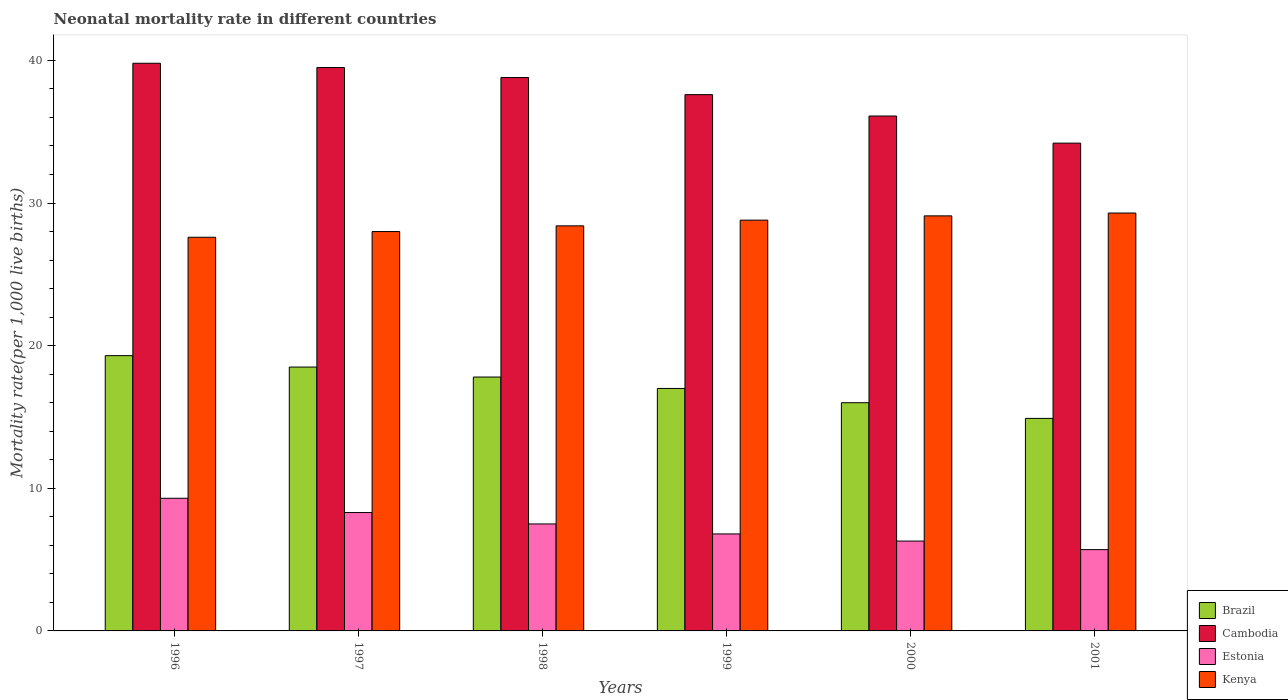How many groups of bars are there?
Provide a short and direct response. 6. How many bars are there on the 1st tick from the left?
Your answer should be compact. 4. What is the neonatal mortality rate in Cambodia in 1997?
Keep it short and to the point. 39.5. Across all years, what is the maximum neonatal mortality rate in Brazil?
Your answer should be compact. 19.3. Across all years, what is the minimum neonatal mortality rate in Cambodia?
Make the answer very short. 34.2. What is the total neonatal mortality rate in Kenya in the graph?
Provide a short and direct response. 171.2. What is the difference between the neonatal mortality rate in Estonia in 1997 and that in 2001?
Your response must be concise. 2.6. What is the difference between the neonatal mortality rate in Cambodia in 2001 and the neonatal mortality rate in Estonia in 1999?
Your response must be concise. 27.4. What is the average neonatal mortality rate in Cambodia per year?
Your response must be concise. 37.67. In the year 1999, what is the difference between the neonatal mortality rate in Kenya and neonatal mortality rate in Brazil?
Ensure brevity in your answer.  11.8. What is the ratio of the neonatal mortality rate in Estonia in 1997 to that in 2000?
Give a very brief answer. 1.32. What is the difference between the highest and the second highest neonatal mortality rate in Estonia?
Your response must be concise. 1. What is the difference between the highest and the lowest neonatal mortality rate in Estonia?
Give a very brief answer. 3.6. Is the sum of the neonatal mortality rate in Brazil in 2000 and 2001 greater than the maximum neonatal mortality rate in Cambodia across all years?
Give a very brief answer. No. What does the 2nd bar from the left in 1996 represents?
Provide a short and direct response. Cambodia. Is it the case that in every year, the sum of the neonatal mortality rate in Cambodia and neonatal mortality rate in Estonia is greater than the neonatal mortality rate in Brazil?
Provide a succinct answer. Yes. How many bars are there?
Ensure brevity in your answer.  24. How many years are there in the graph?
Offer a very short reply. 6. What is the difference between two consecutive major ticks on the Y-axis?
Provide a short and direct response. 10. Are the values on the major ticks of Y-axis written in scientific E-notation?
Offer a terse response. No. Does the graph contain any zero values?
Make the answer very short. No. How many legend labels are there?
Keep it short and to the point. 4. What is the title of the graph?
Your response must be concise. Neonatal mortality rate in different countries. What is the label or title of the X-axis?
Offer a terse response. Years. What is the label or title of the Y-axis?
Offer a very short reply. Mortality rate(per 1,0 live births). What is the Mortality rate(per 1,000 live births) in Brazil in 1996?
Your response must be concise. 19.3. What is the Mortality rate(per 1,000 live births) in Cambodia in 1996?
Give a very brief answer. 39.8. What is the Mortality rate(per 1,000 live births) of Estonia in 1996?
Provide a short and direct response. 9.3. What is the Mortality rate(per 1,000 live births) of Kenya in 1996?
Offer a terse response. 27.6. What is the Mortality rate(per 1,000 live births) of Brazil in 1997?
Offer a very short reply. 18.5. What is the Mortality rate(per 1,000 live births) in Cambodia in 1997?
Offer a very short reply. 39.5. What is the Mortality rate(per 1,000 live births) in Estonia in 1997?
Keep it short and to the point. 8.3. What is the Mortality rate(per 1,000 live births) in Brazil in 1998?
Offer a very short reply. 17.8. What is the Mortality rate(per 1,000 live births) in Cambodia in 1998?
Your response must be concise. 38.8. What is the Mortality rate(per 1,000 live births) in Kenya in 1998?
Provide a succinct answer. 28.4. What is the Mortality rate(per 1,000 live births) in Brazil in 1999?
Your response must be concise. 17. What is the Mortality rate(per 1,000 live births) in Cambodia in 1999?
Offer a terse response. 37.6. What is the Mortality rate(per 1,000 live births) in Kenya in 1999?
Keep it short and to the point. 28.8. What is the Mortality rate(per 1,000 live births) of Brazil in 2000?
Provide a short and direct response. 16. What is the Mortality rate(per 1,000 live births) of Cambodia in 2000?
Provide a succinct answer. 36.1. What is the Mortality rate(per 1,000 live births) of Kenya in 2000?
Your response must be concise. 29.1. What is the Mortality rate(per 1,000 live births) of Brazil in 2001?
Your answer should be very brief. 14.9. What is the Mortality rate(per 1,000 live births) of Cambodia in 2001?
Ensure brevity in your answer.  34.2. What is the Mortality rate(per 1,000 live births) of Kenya in 2001?
Keep it short and to the point. 29.3. Across all years, what is the maximum Mortality rate(per 1,000 live births) in Brazil?
Give a very brief answer. 19.3. Across all years, what is the maximum Mortality rate(per 1,000 live births) of Cambodia?
Provide a succinct answer. 39.8. Across all years, what is the maximum Mortality rate(per 1,000 live births) of Estonia?
Make the answer very short. 9.3. Across all years, what is the maximum Mortality rate(per 1,000 live births) in Kenya?
Ensure brevity in your answer.  29.3. Across all years, what is the minimum Mortality rate(per 1,000 live births) of Cambodia?
Your answer should be very brief. 34.2. Across all years, what is the minimum Mortality rate(per 1,000 live births) of Kenya?
Keep it short and to the point. 27.6. What is the total Mortality rate(per 1,000 live births) in Brazil in the graph?
Your answer should be compact. 103.5. What is the total Mortality rate(per 1,000 live births) in Cambodia in the graph?
Keep it short and to the point. 226. What is the total Mortality rate(per 1,000 live births) of Estonia in the graph?
Keep it short and to the point. 43.9. What is the total Mortality rate(per 1,000 live births) in Kenya in the graph?
Your answer should be very brief. 171.2. What is the difference between the Mortality rate(per 1,000 live births) of Brazil in 1996 and that in 1997?
Give a very brief answer. 0.8. What is the difference between the Mortality rate(per 1,000 live births) of Cambodia in 1996 and that in 1998?
Offer a very short reply. 1. What is the difference between the Mortality rate(per 1,000 live births) in Estonia in 1996 and that in 1998?
Your answer should be compact. 1.8. What is the difference between the Mortality rate(per 1,000 live births) of Kenya in 1996 and that in 1998?
Make the answer very short. -0.8. What is the difference between the Mortality rate(per 1,000 live births) in Brazil in 1996 and that in 1999?
Give a very brief answer. 2.3. What is the difference between the Mortality rate(per 1,000 live births) of Estonia in 1996 and that in 1999?
Provide a succinct answer. 2.5. What is the difference between the Mortality rate(per 1,000 live births) of Kenya in 1996 and that in 1999?
Give a very brief answer. -1.2. What is the difference between the Mortality rate(per 1,000 live births) in Cambodia in 1996 and that in 2000?
Keep it short and to the point. 3.7. What is the difference between the Mortality rate(per 1,000 live births) in Kenya in 1996 and that in 2000?
Offer a very short reply. -1.5. What is the difference between the Mortality rate(per 1,000 live births) of Estonia in 1996 and that in 2001?
Offer a very short reply. 3.6. What is the difference between the Mortality rate(per 1,000 live births) of Brazil in 1997 and that in 1998?
Offer a very short reply. 0.7. What is the difference between the Mortality rate(per 1,000 live births) in Estonia in 1997 and that in 1998?
Provide a succinct answer. 0.8. What is the difference between the Mortality rate(per 1,000 live births) of Kenya in 1997 and that in 1998?
Ensure brevity in your answer.  -0.4. What is the difference between the Mortality rate(per 1,000 live births) in Cambodia in 1997 and that in 1999?
Give a very brief answer. 1.9. What is the difference between the Mortality rate(per 1,000 live births) in Estonia in 1997 and that in 1999?
Keep it short and to the point. 1.5. What is the difference between the Mortality rate(per 1,000 live births) of Brazil in 1997 and that in 2000?
Provide a short and direct response. 2.5. What is the difference between the Mortality rate(per 1,000 live births) in Cambodia in 1997 and that in 2000?
Offer a very short reply. 3.4. What is the difference between the Mortality rate(per 1,000 live births) in Estonia in 1997 and that in 2000?
Keep it short and to the point. 2. What is the difference between the Mortality rate(per 1,000 live births) in Brazil in 1997 and that in 2001?
Your answer should be compact. 3.6. What is the difference between the Mortality rate(per 1,000 live births) in Kenya in 1997 and that in 2001?
Your answer should be very brief. -1.3. What is the difference between the Mortality rate(per 1,000 live births) of Cambodia in 1998 and that in 1999?
Your answer should be very brief. 1.2. What is the difference between the Mortality rate(per 1,000 live births) in Brazil in 1998 and that in 2000?
Keep it short and to the point. 1.8. What is the difference between the Mortality rate(per 1,000 live births) in Kenya in 1998 and that in 2000?
Offer a terse response. -0.7. What is the difference between the Mortality rate(per 1,000 live births) in Brazil in 1998 and that in 2001?
Provide a succinct answer. 2.9. What is the difference between the Mortality rate(per 1,000 live births) of Estonia in 1998 and that in 2001?
Your answer should be very brief. 1.8. What is the difference between the Mortality rate(per 1,000 live births) in Cambodia in 1999 and that in 2000?
Offer a very short reply. 1.5. What is the difference between the Mortality rate(per 1,000 live births) in Estonia in 1999 and that in 2000?
Provide a short and direct response. 0.5. What is the difference between the Mortality rate(per 1,000 live births) in Kenya in 1999 and that in 2000?
Your response must be concise. -0.3. What is the difference between the Mortality rate(per 1,000 live births) in Kenya in 1999 and that in 2001?
Give a very brief answer. -0.5. What is the difference between the Mortality rate(per 1,000 live births) in Brazil in 1996 and the Mortality rate(per 1,000 live births) in Cambodia in 1997?
Give a very brief answer. -20.2. What is the difference between the Mortality rate(per 1,000 live births) in Cambodia in 1996 and the Mortality rate(per 1,000 live births) in Estonia in 1997?
Offer a terse response. 31.5. What is the difference between the Mortality rate(per 1,000 live births) of Estonia in 1996 and the Mortality rate(per 1,000 live births) of Kenya in 1997?
Give a very brief answer. -18.7. What is the difference between the Mortality rate(per 1,000 live births) of Brazil in 1996 and the Mortality rate(per 1,000 live births) of Cambodia in 1998?
Give a very brief answer. -19.5. What is the difference between the Mortality rate(per 1,000 live births) in Brazil in 1996 and the Mortality rate(per 1,000 live births) in Estonia in 1998?
Ensure brevity in your answer.  11.8. What is the difference between the Mortality rate(per 1,000 live births) in Brazil in 1996 and the Mortality rate(per 1,000 live births) in Kenya in 1998?
Give a very brief answer. -9.1. What is the difference between the Mortality rate(per 1,000 live births) in Cambodia in 1996 and the Mortality rate(per 1,000 live births) in Estonia in 1998?
Provide a succinct answer. 32.3. What is the difference between the Mortality rate(per 1,000 live births) in Cambodia in 1996 and the Mortality rate(per 1,000 live births) in Kenya in 1998?
Provide a succinct answer. 11.4. What is the difference between the Mortality rate(per 1,000 live births) of Estonia in 1996 and the Mortality rate(per 1,000 live births) of Kenya in 1998?
Provide a short and direct response. -19.1. What is the difference between the Mortality rate(per 1,000 live births) in Brazil in 1996 and the Mortality rate(per 1,000 live births) in Cambodia in 1999?
Your answer should be compact. -18.3. What is the difference between the Mortality rate(per 1,000 live births) of Cambodia in 1996 and the Mortality rate(per 1,000 live births) of Estonia in 1999?
Give a very brief answer. 33. What is the difference between the Mortality rate(per 1,000 live births) of Cambodia in 1996 and the Mortality rate(per 1,000 live births) of Kenya in 1999?
Provide a succinct answer. 11. What is the difference between the Mortality rate(per 1,000 live births) in Estonia in 1996 and the Mortality rate(per 1,000 live births) in Kenya in 1999?
Ensure brevity in your answer.  -19.5. What is the difference between the Mortality rate(per 1,000 live births) in Brazil in 1996 and the Mortality rate(per 1,000 live births) in Cambodia in 2000?
Your response must be concise. -16.8. What is the difference between the Mortality rate(per 1,000 live births) in Brazil in 1996 and the Mortality rate(per 1,000 live births) in Kenya in 2000?
Offer a terse response. -9.8. What is the difference between the Mortality rate(per 1,000 live births) of Cambodia in 1996 and the Mortality rate(per 1,000 live births) of Estonia in 2000?
Your answer should be compact. 33.5. What is the difference between the Mortality rate(per 1,000 live births) of Estonia in 1996 and the Mortality rate(per 1,000 live births) of Kenya in 2000?
Offer a very short reply. -19.8. What is the difference between the Mortality rate(per 1,000 live births) of Brazil in 1996 and the Mortality rate(per 1,000 live births) of Cambodia in 2001?
Give a very brief answer. -14.9. What is the difference between the Mortality rate(per 1,000 live births) in Brazil in 1996 and the Mortality rate(per 1,000 live births) in Estonia in 2001?
Your answer should be very brief. 13.6. What is the difference between the Mortality rate(per 1,000 live births) of Cambodia in 1996 and the Mortality rate(per 1,000 live births) of Estonia in 2001?
Your answer should be compact. 34.1. What is the difference between the Mortality rate(per 1,000 live births) of Cambodia in 1996 and the Mortality rate(per 1,000 live births) of Kenya in 2001?
Ensure brevity in your answer.  10.5. What is the difference between the Mortality rate(per 1,000 live births) of Estonia in 1996 and the Mortality rate(per 1,000 live births) of Kenya in 2001?
Provide a succinct answer. -20. What is the difference between the Mortality rate(per 1,000 live births) in Brazil in 1997 and the Mortality rate(per 1,000 live births) in Cambodia in 1998?
Your answer should be very brief. -20.3. What is the difference between the Mortality rate(per 1,000 live births) in Brazil in 1997 and the Mortality rate(per 1,000 live births) in Estonia in 1998?
Ensure brevity in your answer.  11. What is the difference between the Mortality rate(per 1,000 live births) of Cambodia in 1997 and the Mortality rate(per 1,000 live births) of Estonia in 1998?
Give a very brief answer. 32. What is the difference between the Mortality rate(per 1,000 live births) of Estonia in 1997 and the Mortality rate(per 1,000 live births) of Kenya in 1998?
Provide a short and direct response. -20.1. What is the difference between the Mortality rate(per 1,000 live births) of Brazil in 1997 and the Mortality rate(per 1,000 live births) of Cambodia in 1999?
Offer a terse response. -19.1. What is the difference between the Mortality rate(per 1,000 live births) of Brazil in 1997 and the Mortality rate(per 1,000 live births) of Estonia in 1999?
Provide a succinct answer. 11.7. What is the difference between the Mortality rate(per 1,000 live births) of Brazil in 1997 and the Mortality rate(per 1,000 live births) of Kenya in 1999?
Offer a terse response. -10.3. What is the difference between the Mortality rate(per 1,000 live births) in Cambodia in 1997 and the Mortality rate(per 1,000 live births) in Estonia in 1999?
Offer a very short reply. 32.7. What is the difference between the Mortality rate(per 1,000 live births) in Cambodia in 1997 and the Mortality rate(per 1,000 live births) in Kenya in 1999?
Keep it short and to the point. 10.7. What is the difference between the Mortality rate(per 1,000 live births) in Estonia in 1997 and the Mortality rate(per 1,000 live births) in Kenya in 1999?
Offer a very short reply. -20.5. What is the difference between the Mortality rate(per 1,000 live births) of Brazil in 1997 and the Mortality rate(per 1,000 live births) of Cambodia in 2000?
Ensure brevity in your answer.  -17.6. What is the difference between the Mortality rate(per 1,000 live births) of Brazil in 1997 and the Mortality rate(per 1,000 live births) of Estonia in 2000?
Your answer should be very brief. 12.2. What is the difference between the Mortality rate(per 1,000 live births) of Brazil in 1997 and the Mortality rate(per 1,000 live births) of Kenya in 2000?
Your answer should be very brief. -10.6. What is the difference between the Mortality rate(per 1,000 live births) of Cambodia in 1997 and the Mortality rate(per 1,000 live births) of Estonia in 2000?
Provide a short and direct response. 33.2. What is the difference between the Mortality rate(per 1,000 live births) in Cambodia in 1997 and the Mortality rate(per 1,000 live births) in Kenya in 2000?
Ensure brevity in your answer.  10.4. What is the difference between the Mortality rate(per 1,000 live births) of Estonia in 1997 and the Mortality rate(per 1,000 live births) of Kenya in 2000?
Your answer should be very brief. -20.8. What is the difference between the Mortality rate(per 1,000 live births) in Brazil in 1997 and the Mortality rate(per 1,000 live births) in Cambodia in 2001?
Offer a very short reply. -15.7. What is the difference between the Mortality rate(per 1,000 live births) in Brazil in 1997 and the Mortality rate(per 1,000 live births) in Kenya in 2001?
Make the answer very short. -10.8. What is the difference between the Mortality rate(per 1,000 live births) in Cambodia in 1997 and the Mortality rate(per 1,000 live births) in Estonia in 2001?
Keep it short and to the point. 33.8. What is the difference between the Mortality rate(per 1,000 live births) in Estonia in 1997 and the Mortality rate(per 1,000 live births) in Kenya in 2001?
Offer a very short reply. -21. What is the difference between the Mortality rate(per 1,000 live births) in Brazil in 1998 and the Mortality rate(per 1,000 live births) in Cambodia in 1999?
Your answer should be compact. -19.8. What is the difference between the Mortality rate(per 1,000 live births) of Brazil in 1998 and the Mortality rate(per 1,000 live births) of Estonia in 1999?
Offer a very short reply. 11. What is the difference between the Mortality rate(per 1,000 live births) in Estonia in 1998 and the Mortality rate(per 1,000 live births) in Kenya in 1999?
Provide a succinct answer. -21.3. What is the difference between the Mortality rate(per 1,000 live births) in Brazil in 1998 and the Mortality rate(per 1,000 live births) in Cambodia in 2000?
Your answer should be very brief. -18.3. What is the difference between the Mortality rate(per 1,000 live births) of Brazil in 1998 and the Mortality rate(per 1,000 live births) of Kenya in 2000?
Make the answer very short. -11.3. What is the difference between the Mortality rate(per 1,000 live births) of Cambodia in 1998 and the Mortality rate(per 1,000 live births) of Estonia in 2000?
Offer a very short reply. 32.5. What is the difference between the Mortality rate(per 1,000 live births) of Estonia in 1998 and the Mortality rate(per 1,000 live births) of Kenya in 2000?
Ensure brevity in your answer.  -21.6. What is the difference between the Mortality rate(per 1,000 live births) in Brazil in 1998 and the Mortality rate(per 1,000 live births) in Cambodia in 2001?
Provide a short and direct response. -16.4. What is the difference between the Mortality rate(per 1,000 live births) of Cambodia in 1998 and the Mortality rate(per 1,000 live births) of Estonia in 2001?
Offer a terse response. 33.1. What is the difference between the Mortality rate(per 1,000 live births) in Cambodia in 1998 and the Mortality rate(per 1,000 live births) in Kenya in 2001?
Make the answer very short. 9.5. What is the difference between the Mortality rate(per 1,000 live births) of Estonia in 1998 and the Mortality rate(per 1,000 live births) of Kenya in 2001?
Provide a succinct answer. -21.8. What is the difference between the Mortality rate(per 1,000 live births) of Brazil in 1999 and the Mortality rate(per 1,000 live births) of Cambodia in 2000?
Offer a terse response. -19.1. What is the difference between the Mortality rate(per 1,000 live births) of Brazil in 1999 and the Mortality rate(per 1,000 live births) of Estonia in 2000?
Your answer should be compact. 10.7. What is the difference between the Mortality rate(per 1,000 live births) in Brazil in 1999 and the Mortality rate(per 1,000 live births) in Kenya in 2000?
Keep it short and to the point. -12.1. What is the difference between the Mortality rate(per 1,000 live births) in Cambodia in 1999 and the Mortality rate(per 1,000 live births) in Estonia in 2000?
Offer a terse response. 31.3. What is the difference between the Mortality rate(per 1,000 live births) in Cambodia in 1999 and the Mortality rate(per 1,000 live births) in Kenya in 2000?
Your answer should be compact. 8.5. What is the difference between the Mortality rate(per 1,000 live births) in Estonia in 1999 and the Mortality rate(per 1,000 live births) in Kenya in 2000?
Your answer should be compact. -22.3. What is the difference between the Mortality rate(per 1,000 live births) in Brazil in 1999 and the Mortality rate(per 1,000 live births) in Cambodia in 2001?
Your response must be concise. -17.2. What is the difference between the Mortality rate(per 1,000 live births) of Brazil in 1999 and the Mortality rate(per 1,000 live births) of Kenya in 2001?
Offer a very short reply. -12.3. What is the difference between the Mortality rate(per 1,000 live births) of Cambodia in 1999 and the Mortality rate(per 1,000 live births) of Estonia in 2001?
Offer a very short reply. 31.9. What is the difference between the Mortality rate(per 1,000 live births) of Estonia in 1999 and the Mortality rate(per 1,000 live births) of Kenya in 2001?
Your answer should be very brief. -22.5. What is the difference between the Mortality rate(per 1,000 live births) in Brazil in 2000 and the Mortality rate(per 1,000 live births) in Cambodia in 2001?
Make the answer very short. -18.2. What is the difference between the Mortality rate(per 1,000 live births) of Brazil in 2000 and the Mortality rate(per 1,000 live births) of Kenya in 2001?
Provide a short and direct response. -13.3. What is the difference between the Mortality rate(per 1,000 live births) of Cambodia in 2000 and the Mortality rate(per 1,000 live births) of Estonia in 2001?
Your answer should be compact. 30.4. What is the difference between the Mortality rate(per 1,000 live births) in Cambodia in 2000 and the Mortality rate(per 1,000 live births) in Kenya in 2001?
Your response must be concise. 6.8. What is the difference between the Mortality rate(per 1,000 live births) in Estonia in 2000 and the Mortality rate(per 1,000 live births) in Kenya in 2001?
Offer a very short reply. -23. What is the average Mortality rate(per 1,000 live births) of Brazil per year?
Provide a succinct answer. 17.25. What is the average Mortality rate(per 1,000 live births) in Cambodia per year?
Keep it short and to the point. 37.67. What is the average Mortality rate(per 1,000 live births) of Estonia per year?
Your response must be concise. 7.32. What is the average Mortality rate(per 1,000 live births) in Kenya per year?
Your answer should be very brief. 28.53. In the year 1996, what is the difference between the Mortality rate(per 1,000 live births) in Brazil and Mortality rate(per 1,000 live births) in Cambodia?
Offer a very short reply. -20.5. In the year 1996, what is the difference between the Mortality rate(per 1,000 live births) of Brazil and Mortality rate(per 1,000 live births) of Estonia?
Give a very brief answer. 10. In the year 1996, what is the difference between the Mortality rate(per 1,000 live births) in Cambodia and Mortality rate(per 1,000 live births) in Estonia?
Give a very brief answer. 30.5. In the year 1996, what is the difference between the Mortality rate(per 1,000 live births) in Estonia and Mortality rate(per 1,000 live births) in Kenya?
Ensure brevity in your answer.  -18.3. In the year 1997, what is the difference between the Mortality rate(per 1,000 live births) in Brazil and Mortality rate(per 1,000 live births) in Cambodia?
Provide a succinct answer. -21. In the year 1997, what is the difference between the Mortality rate(per 1,000 live births) of Brazil and Mortality rate(per 1,000 live births) of Estonia?
Give a very brief answer. 10.2. In the year 1997, what is the difference between the Mortality rate(per 1,000 live births) of Brazil and Mortality rate(per 1,000 live births) of Kenya?
Ensure brevity in your answer.  -9.5. In the year 1997, what is the difference between the Mortality rate(per 1,000 live births) of Cambodia and Mortality rate(per 1,000 live births) of Estonia?
Make the answer very short. 31.2. In the year 1997, what is the difference between the Mortality rate(per 1,000 live births) of Cambodia and Mortality rate(per 1,000 live births) of Kenya?
Your answer should be compact. 11.5. In the year 1997, what is the difference between the Mortality rate(per 1,000 live births) in Estonia and Mortality rate(per 1,000 live births) in Kenya?
Provide a succinct answer. -19.7. In the year 1998, what is the difference between the Mortality rate(per 1,000 live births) of Brazil and Mortality rate(per 1,000 live births) of Estonia?
Provide a succinct answer. 10.3. In the year 1998, what is the difference between the Mortality rate(per 1,000 live births) in Brazil and Mortality rate(per 1,000 live births) in Kenya?
Your answer should be very brief. -10.6. In the year 1998, what is the difference between the Mortality rate(per 1,000 live births) of Cambodia and Mortality rate(per 1,000 live births) of Estonia?
Offer a very short reply. 31.3. In the year 1998, what is the difference between the Mortality rate(per 1,000 live births) in Estonia and Mortality rate(per 1,000 live births) in Kenya?
Provide a succinct answer. -20.9. In the year 1999, what is the difference between the Mortality rate(per 1,000 live births) in Brazil and Mortality rate(per 1,000 live births) in Cambodia?
Your answer should be very brief. -20.6. In the year 1999, what is the difference between the Mortality rate(per 1,000 live births) of Brazil and Mortality rate(per 1,000 live births) of Estonia?
Keep it short and to the point. 10.2. In the year 1999, what is the difference between the Mortality rate(per 1,000 live births) of Brazil and Mortality rate(per 1,000 live births) of Kenya?
Give a very brief answer. -11.8. In the year 1999, what is the difference between the Mortality rate(per 1,000 live births) of Cambodia and Mortality rate(per 1,000 live births) of Estonia?
Provide a succinct answer. 30.8. In the year 1999, what is the difference between the Mortality rate(per 1,000 live births) in Estonia and Mortality rate(per 1,000 live births) in Kenya?
Your answer should be very brief. -22. In the year 2000, what is the difference between the Mortality rate(per 1,000 live births) in Brazil and Mortality rate(per 1,000 live births) in Cambodia?
Ensure brevity in your answer.  -20.1. In the year 2000, what is the difference between the Mortality rate(per 1,000 live births) in Brazil and Mortality rate(per 1,000 live births) in Estonia?
Your response must be concise. 9.7. In the year 2000, what is the difference between the Mortality rate(per 1,000 live births) of Brazil and Mortality rate(per 1,000 live births) of Kenya?
Ensure brevity in your answer.  -13.1. In the year 2000, what is the difference between the Mortality rate(per 1,000 live births) in Cambodia and Mortality rate(per 1,000 live births) in Estonia?
Your response must be concise. 29.8. In the year 2000, what is the difference between the Mortality rate(per 1,000 live births) of Estonia and Mortality rate(per 1,000 live births) of Kenya?
Give a very brief answer. -22.8. In the year 2001, what is the difference between the Mortality rate(per 1,000 live births) of Brazil and Mortality rate(per 1,000 live births) of Cambodia?
Offer a very short reply. -19.3. In the year 2001, what is the difference between the Mortality rate(per 1,000 live births) of Brazil and Mortality rate(per 1,000 live births) of Kenya?
Your answer should be very brief. -14.4. In the year 2001, what is the difference between the Mortality rate(per 1,000 live births) in Estonia and Mortality rate(per 1,000 live births) in Kenya?
Make the answer very short. -23.6. What is the ratio of the Mortality rate(per 1,000 live births) in Brazil in 1996 to that in 1997?
Offer a very short reply. 1.04. What is the ratio of the Mortality rate(per 1,000 live births) in Cambodia in 1996 to that in 1997?
Provide a short and direct response. 1.01. What is the ratio of the Mortality rate(per 1,000 live births) in Estonia in 1996 to that in 1997?
Your answer should be compact. 1.12. What is the ratio of the Mortality rate(per 1,000 live births) in Kenya in 1996 to that in 1997?
Ensure brevity in your answer.  0.99. What is the ratio of the Mortality rate(per 1,000 live births) in Brazil in 1996 to that in 1998?
Ensure brevity in your answer.  1.08. What is the ratio of the Mortality rate(per 1,000 live births) in Cambodia in 1996 to that in 1998?
Keep it short and to the point. 1.03. What is the ratio of the Mortality rate(per 1,000 live births) in Estonia in 1996 to that in 1998?
Keep it short and to the point. 1.24. What is the ratio of the Mortality rate(per 1,000 live births) in Kenya in 1996 to that in 1998?
Your answer should be compact. 0.97. What is the ratio of the Mortality rate(per 1,000 live births) in Brazil in 1996 to that in 1999?
Your answer should be very brief. 1.14. What is the ratio of the Mortality rate(per 1,000 live births) of Cambodia in 1996 to that in 1999?
Give a very brief answer. 1.06. What is the ratio of the Mortality rate(per 1,000 live births) of Estonia in 1996 to that in 1999?
Give a very brief answer. 1.37. What is the ratio of the Mortality rate(per 1,000 live births) in Brazil in 1996 to that in 2000?
Ensure brevity in your answer.  1.21. What is the ratio of the Mortality rate(per 1,000 live births) of Cambodia in 1996 to that in 2000?
Offer a terse response. 1.1. What is the ratio of the Mortality rate(per 1,000 live births) of Estonia in 1996 to that in 2000?
Provide a succinct answer. 1.48. What is the ratio of the Mortality rate(per 1,000 live births) of Kenya in 1996 to that in 2000?
Ensure brevity in your answer.  0.95. What is the ratio of the Mortality rate(per 1,000 live births) in Brazil in 1996 to that in 2001?
Make the answer very short. 1.3. What is the ratio of the Mortality rate(per 1,000 live births) in Cambodia in 1996 to that in 2001?
Your answer should be very brief. 1.16. What is the ratio of the Mortality rate(per 1,000 live births) in Estonia in 1996 to that in 2001?
Provide a succinct answer. 1.63. What is the ratio of the Mortality rate(per 1,000 live births) of Kenya in 1996 to that in 2001?
Your response must be concise. 0.94. What is the ratio of the Mortality rate(per 1,000 live births) of Brazil in 1997 to that in 1998?
Give a very brief answer. 1.04. What is the ratio of the Mortality rate(per 1,000 live births) of Estonia in 1997 to that in 1998?
Give a very brief answer. 1.11. What is the ratio of the Mortality rate(per 1,000 live births) in Kenya in 1997 to that in 1998?
Your answer should be very brief. 0.99. What is the ratio of the Mortality rate(per 1,000 live births) of Brazil in 1997 to that in 1999?
Make the answer very short. 1.09. What is the ratio of the Mortality rate(per 1,000 live births) of Cambodia in 1997 to that in 1999?
Offer a very short reply. 1.05. What is the ratio of the Mortality rate(per 1,000 live births) in Estonia in 1997 to that in 1999?
Provide a succinct answer. 1.22. What is the ratio of the Mortality rate(per 1,000 live births) of Kenya in 1997 to that in 1999?
Make the answer very short. 0.97. What is the ratio of the Mortality rate(per 1,000 live births) of Brazil in 1997 to that in 2000?
Ensure brevity in your answer.  1.16. What is the ratio of the Mortality rate(per 1,000 live births) of Cambodia in 1997 to that in 2000?
Keep it short and to the point. 1.09. What is the ratio of the Mortality rate(per 1,000 live births) of Estonia in 1997 to that in 2000?
Your answer should be very brief. 1.32. What is the ratio of the Mortality rate(per 1,000 live births) of Kenya in 1997 to that in 2000?
Provide a short and direct response. 0.96. What is the ratio of the Mortality rate(per 1,000 live births) of Brazil in 1997 to that in 2001?
Offer a very short reply. 1.24. What is the ratio of the Mortality rate(per 1,000 live births) in Cambodia in 1997 to that in 2001?
Offer a terse response. 1.16. What is the ratio of the Mortality rate(per 1,000 live births) in Estonia in 1997 to that in 2001?
Keep it short and to the point. 1.46. What is the ratio of the Mortality rate(per 1,000 live births) of Kenya in 1997 to that in 2001?
Your response must be concise. 0.96. What is the ratio of the Mortality rate(per 1,000 live births) of Brazil in 1998 to that in 1999?
Your answer should be very brief. 1.05. What is the ratio of the Mortality rate(per 1,000 live births) in Cambodia in 1998 to that in 1999?
Provide a short and direct response. 1.03. What is the ratio of the Mortality rate(per 1,000 live births) in Estonia in 1998 to that in 1999?
Provide a short and direct response. 1.1. What is the ratio of the Mortality rate(per 1,000 live births) in Kenya in 1998 to that in 1999?
Offer a very short reply. 0.99. What is the ratio of the Mortality rate(per 1,000 live births) of Brazil in 1998 to that in 2000?
Ensure brevity in your answer.  1.11. What is the ratio of the Mortality rate(per 1,000 live births) of Cambodia in 1998 to that in 2000?
Your answer should be very brief. 1.07. What is the ratio of the Mortality rate(per 1,000 live births) in Estonia in 1998 to that in 2000?
Give a very brief answer. 1.19. What is the ratio of the Mortality rate(per 1,000 live births) of Kenya in 1998 to that in 2000?
Your answer should be very brief. 0.98. What is the ratio of the Mortality rate(per 1,000 live births) of Brazil in 1998 to that in 2001?
Offer a very short reply. 1.19. What is the ratio of the Mortality rate(per 1,000 live births) of Cambodia in 1998 to that in 2001?
Keep it short and to the point. 1.13. What is the ratio of the Mortality rate(per 1,000 live births) in Estonia in 1998 to that in 2001?
Give a very brief answer. 1.32. What is the ratio of the Mortality rate(per 1,000 live births) of Kenya in 1998 to that in 2001?
Provide a short and direct response. 0.97. What is the ratio of the Mortality rate(per 1,000 live births) in Brazil in 1999 to that in 2000?
Offer a terse response. 1.06. What is the ratio of the Mortality rate(per 1,000 live births) in Cambodia in 1999 to that in 2000?
Provide a succinct answer. 1.04. What is the ratio of the Mortality rate(per 1,000 live births) of Estonia in 1999 to that in 2000?
Ensure brevity in your answer.  1.08. What is the ratio of the Mortality rate(per 1,000 live births) in Brazil in 1999 to that in 2001?
Offer a terse response. 1.14. What is the ratio of the Mortality rate(per 1,000 live births) in Cambodia in 1999 to that in 2001?
Provide a short and direct response. 1.1. What is the ratio of the Mortality rate(per 1,000 live births) in Estonia in 1999 to that in 2001?
Offer a very short reply. 1.19. What is the ratio of the Mortality rate(per 1,000 live births) of Kenya in 1999 to that in 2001?
Offer a terse response. 0.98. What is the ratio of the Mortality rate(per 1,000 live births) in Brazil in 2000 to that in 2001?
Provide a succinct answer. 1.07. What is the ratio of the Mortality rate(per 1,000 live births) in Cambodia in 2000 to that in 2001?
Your answer should be very brief. 1.06. What is the ratio of the Mortality rate(per 1,000 live births) in Estonia in 2000 to that in 2001?
Keep it short and to the point. 1.11. What is the difference between the highest and the second highest Mortality rate(per 1,000 live births) in Brazil?
Your answer should be very brief. 0.8. What is the difference between the highest and the second highest Mortality rate(per 1,000 live births) of Estonia?
Offer a very short reply. 1. What is the difference between the highest and the lowest Mortality rate(per 1,000 live births) of Estonia?
Your answer should be very brief. 3.6. 